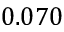<formula> <loc_0><loc_0><loc_500><loc_500>0 . 0 7 0</formula> 